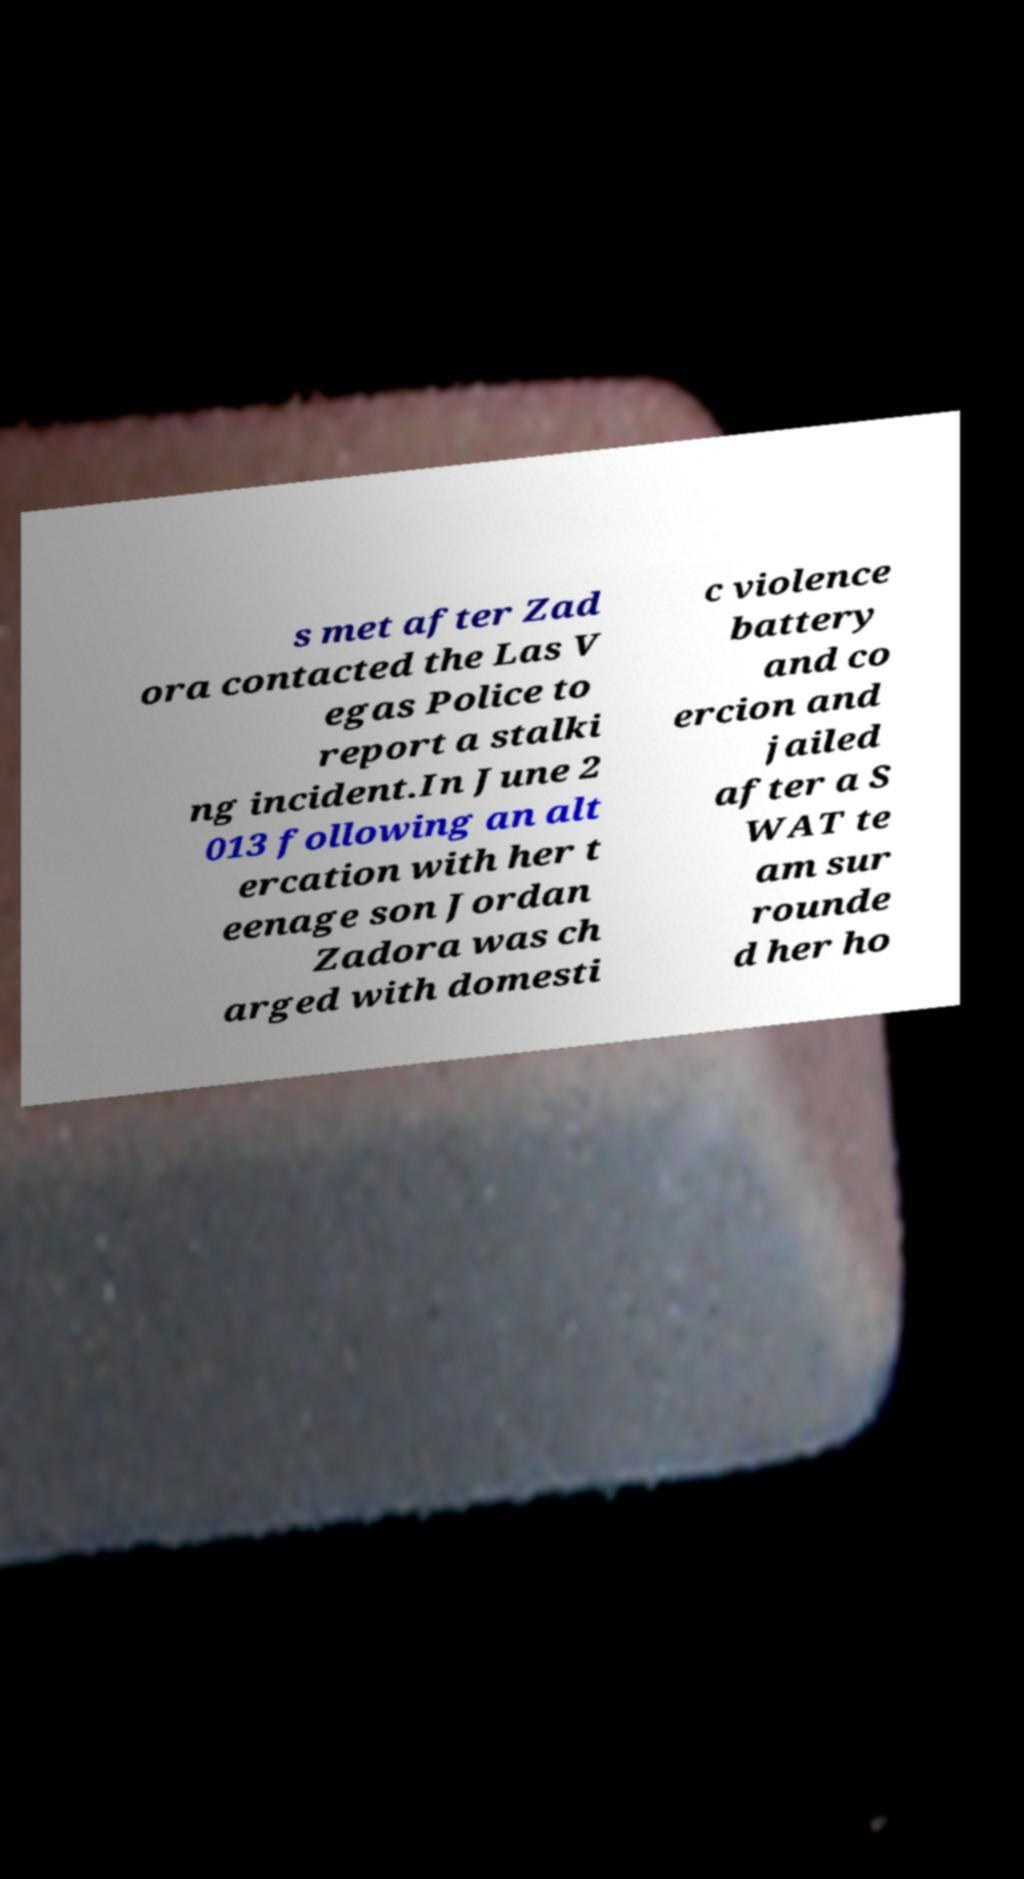What messages or text are displayed in this image? I need them in a readable, typed format. s met after Zad ora contacted the Las V egas Police to report a stalki ng incident.In June 2 013 following an alt ercation with her t eenage son Jordan Zadora was ch arged with domesti c violence battery and co ercion and jailed after a S WAT te am sur rounde d her ho 